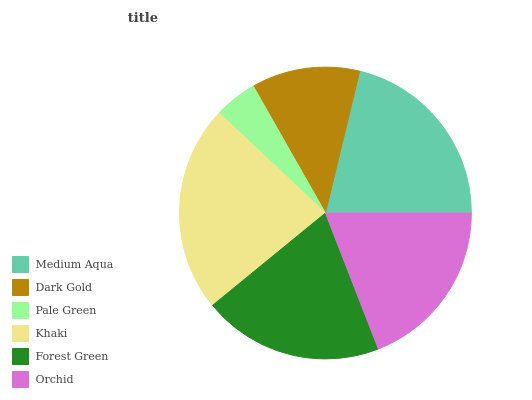Is Pale Green the minimum?
Answer yes or no. Yes. Is Khaki the maximum?
Answer yes or no. Yes. Is Dark Gold the minimum?
Answer yes or no. No. Is Dark Gold the maximum?
Answer yes or no. No. Is Medium Aqua greater than Dark Gold?
Answer yes or no. Yes. Is Dark Gold less than Medium Aqua?
Answer yes or no. Yes. Is Dark Gold greater than Medium Aqua?
Answer yes or no. No. Is Medium Aqua less than Dark Gold?
Answer yes or no. No. Is Forest Green the high median?
Answer yes or no. Yes. Is Orchid the low median?
Answer yes or no. Yes. Is Khaki the high median?
Answer yes or no. No. Is Forest Green the low median?
Answer yes or no. No. 